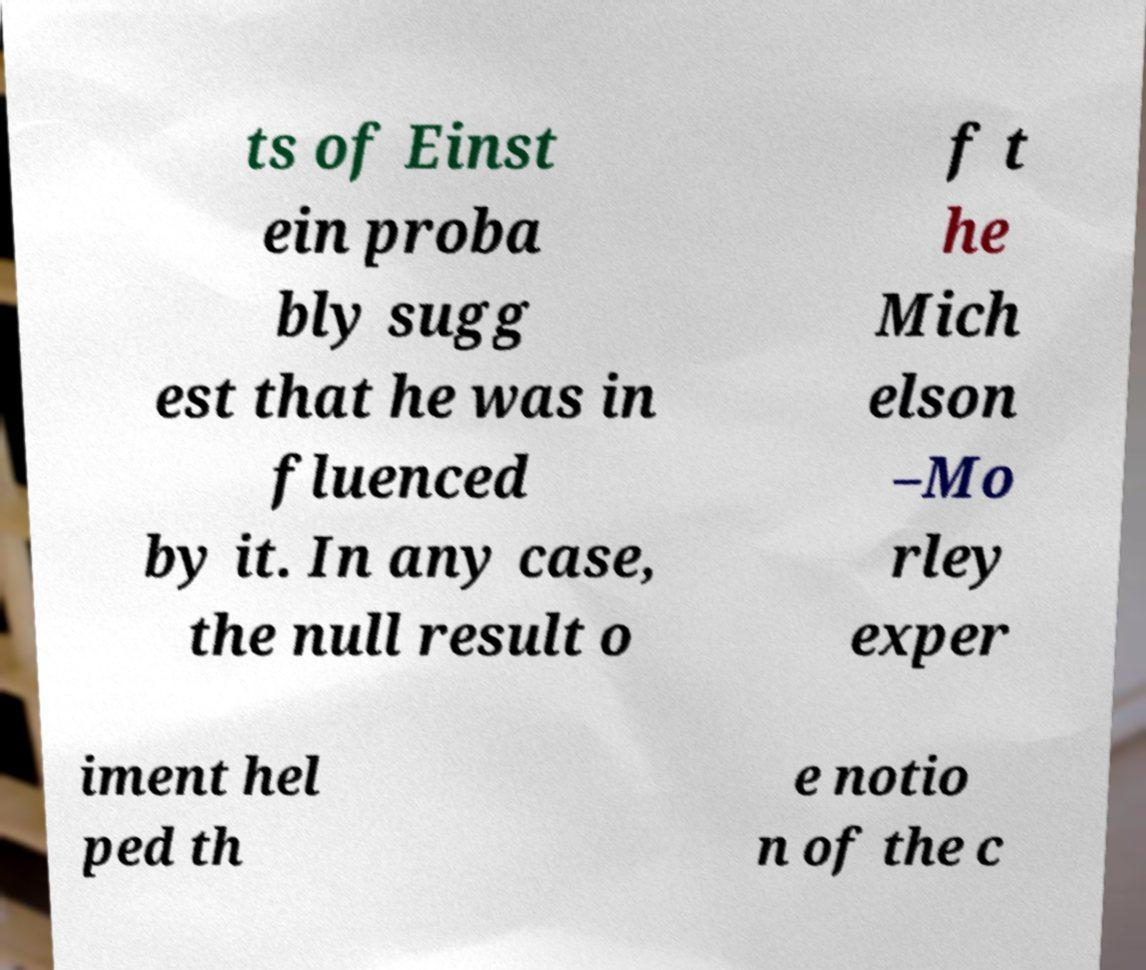What messages or text are displayed in this image? I need them in a readable, typed format. ts of Einst ein proba bly sugg est that he was in fluenced by it. In any case, the null result o f t he Mich elson –Mo rley exper iment hel ped th e notio n of the c 